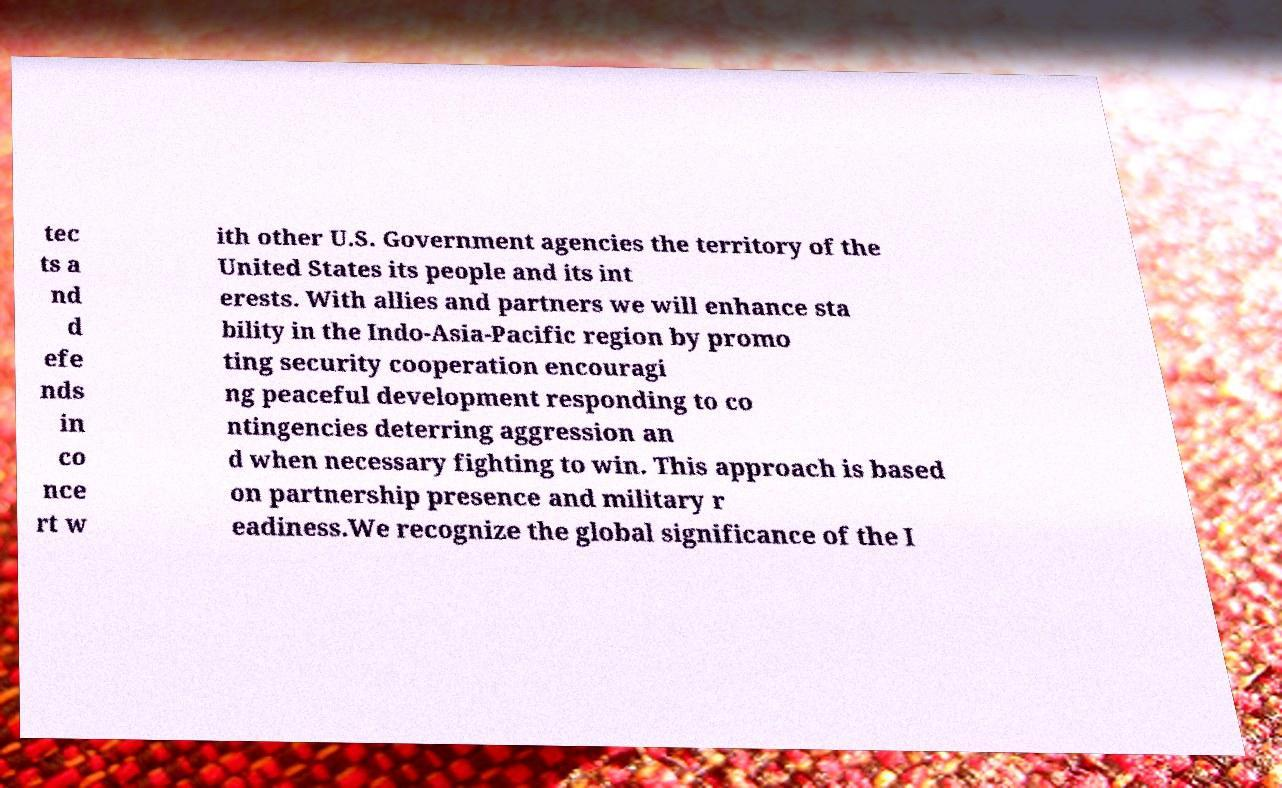I need the written content from this picture converted into text. Can you do that? tec ts a nd d efe nds in co nce rt w ith other U.S. Government agencies the territory of the United States its people and its int erests. With allies and partners we will enhance sta bility in the Indo-Asia-Pacific region by promo ting security cooperation encouragi ng peaceful development responding to co ntingencies deterring aggression an d when necessary fighting to win. This approach is based on partnership presence and military r eadiness.We recognize the global significance of the I 